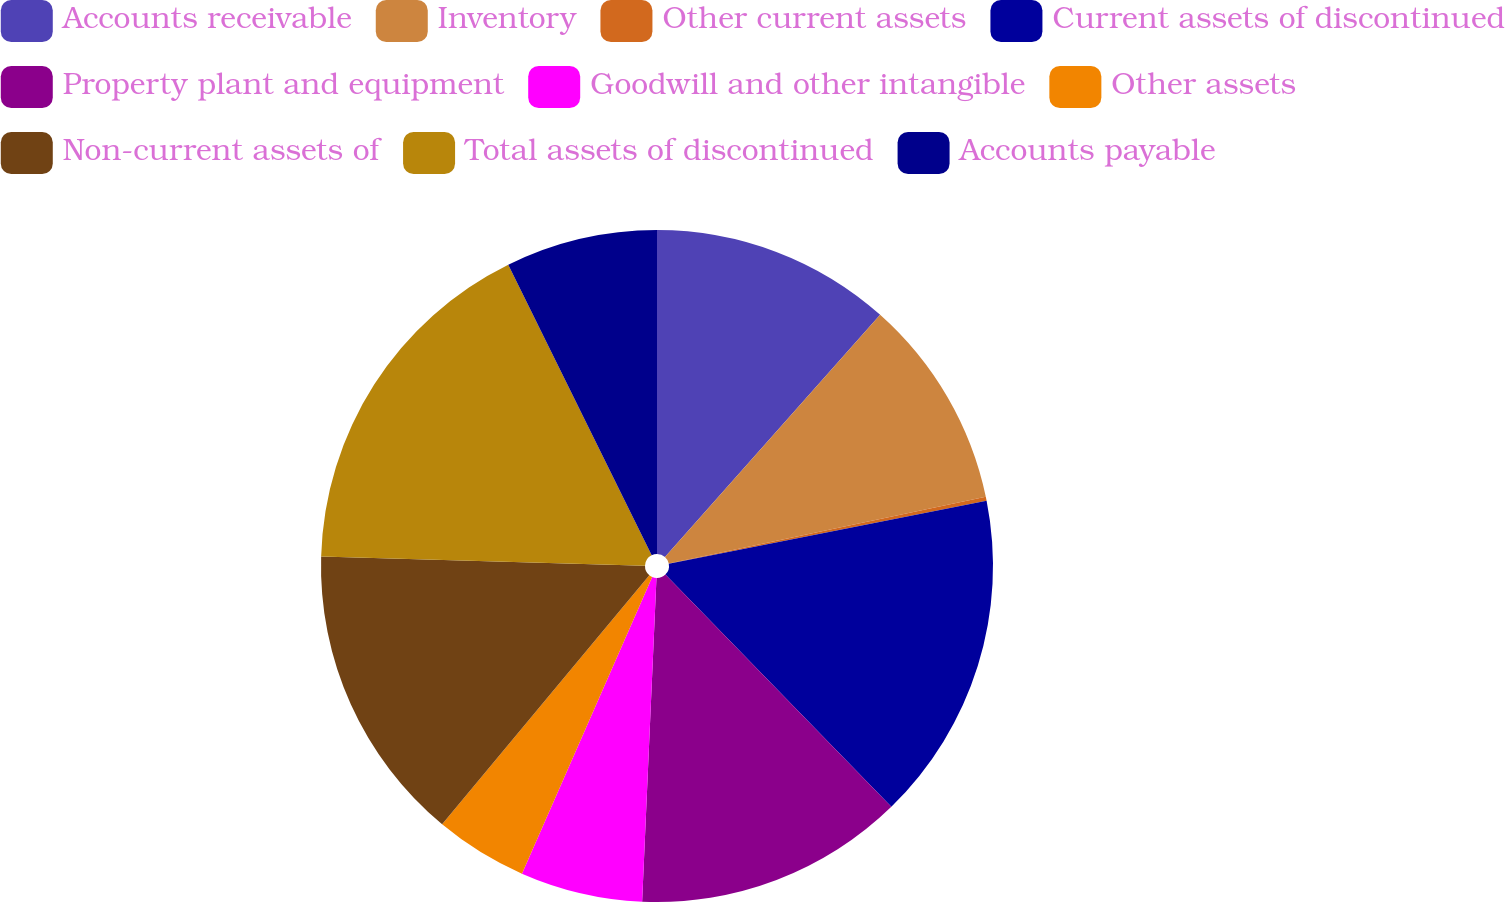Convert chart. <chart><loc_0><loc_0><loc_500><loc_500><pie_chart><fcel>Accounts receivable<fcel>Inventory<fcel>Other current assets<fcel>Current assets of discontinued<fcel>Property plant and equipment<fcel>Goodwill and other intangible<fcel>Other assets<fcel>Non-current assets of<fcel>Total assets of discontinued<fcel>Accounts payable<nl><fcel>11.56%<fcel>10.14%<fcel>0.19%<fcel>15.83%<fcel>12.99%<fcel>5.88%<fcel>4.46%<fcel>14.41%<fcel>17.25%<fcel>7.3%<nl></chart> 